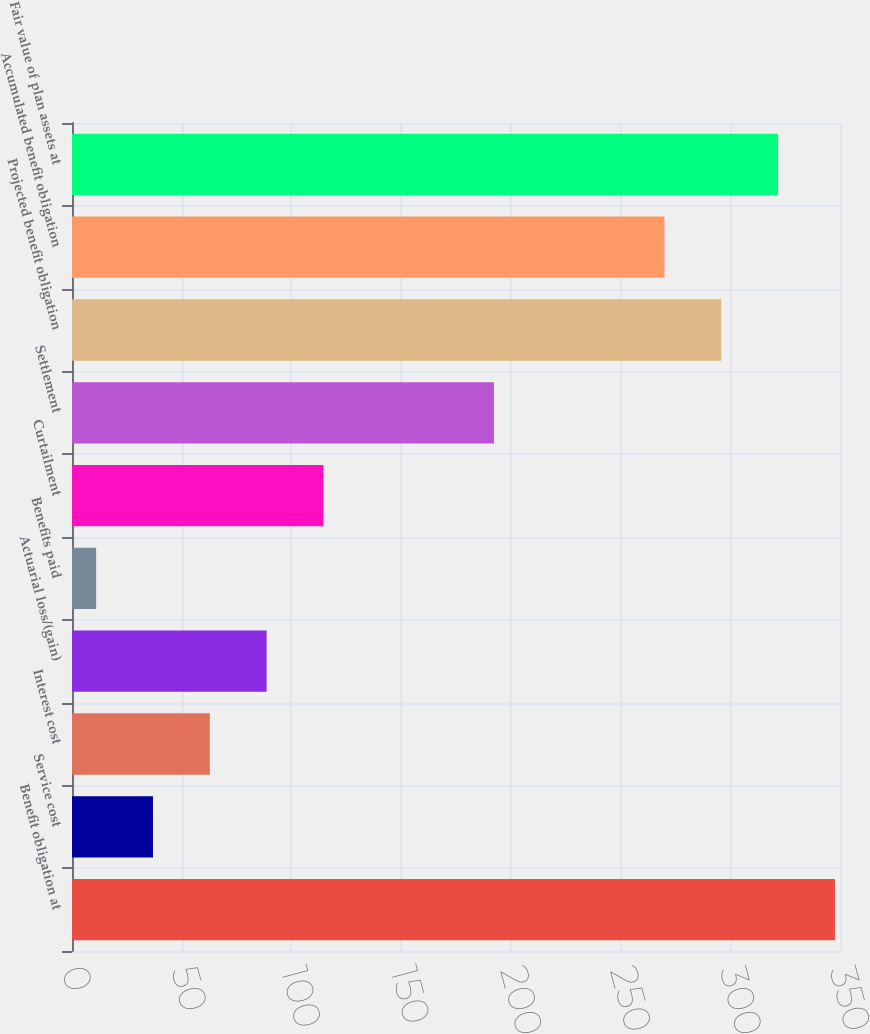Convert chart to OTSL. <chart><loc_0><loc_0><loc_500><loc_500><bar_chart><fcel>Benefit obligation at<fcel>Service cost<fcel>Interest cost<fcel>Actuarial loss/(gain)<fcel>Benefits paid<fcel>Curtailment<fcel>Settlement<fcel>Projected benefit obligation<fcel>Accumulated benefit obligation<fcel>Fair value of plan assets at<nl><fcel>347.7<fcel>36.9<fcel>62.8<fcel>88.7<fcel>11<fcel>114.6<fcel>192.3<fcel>295.9<fcel>270<fcel>321.8<nl></chart> 